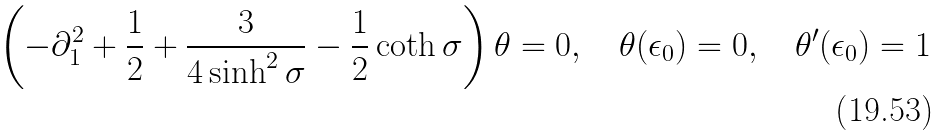Convert formula to latex. <formula><loc_0><loc_0><loc_500><loc_500>\left ( - \partial _ { 1 } ^ { 2 } + \frac { 1 } { 2 } + \frac { 3 } { 4 \sinh ^ { 2 } \sigma } - \frac { 1 } { 2 } \coth \sigma \right ) \theta = 0 , \quad \theta ( \epsilon _ { 0 } ) = 0 , \quad \theta ^ { \prime } ( \epsilon _ { 0 } ) = 1</formula> 